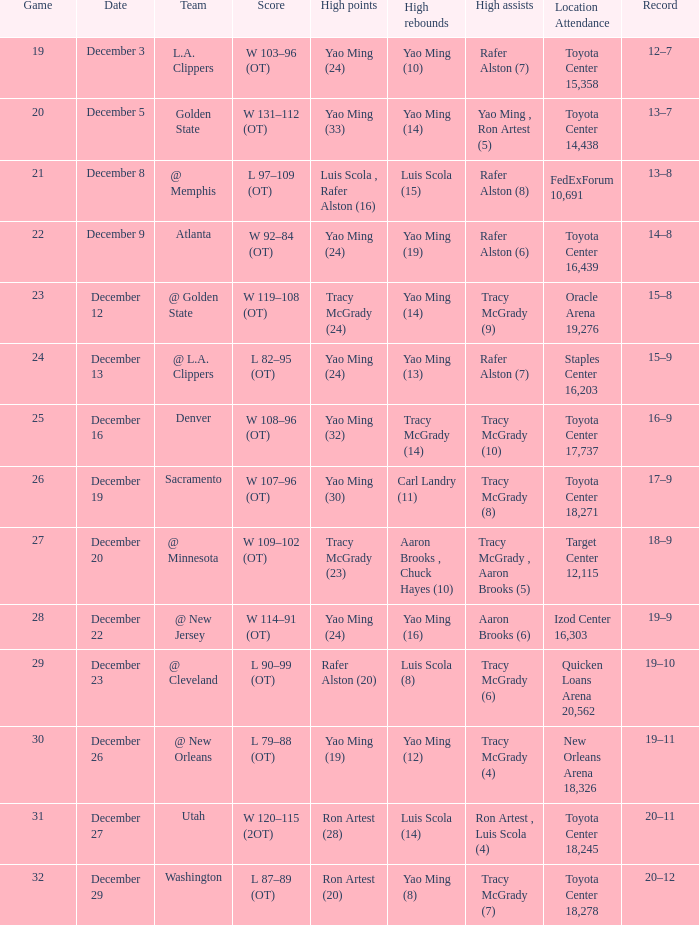On what date does tracy mcgrady (8) have the highest number of assists? December 19. 